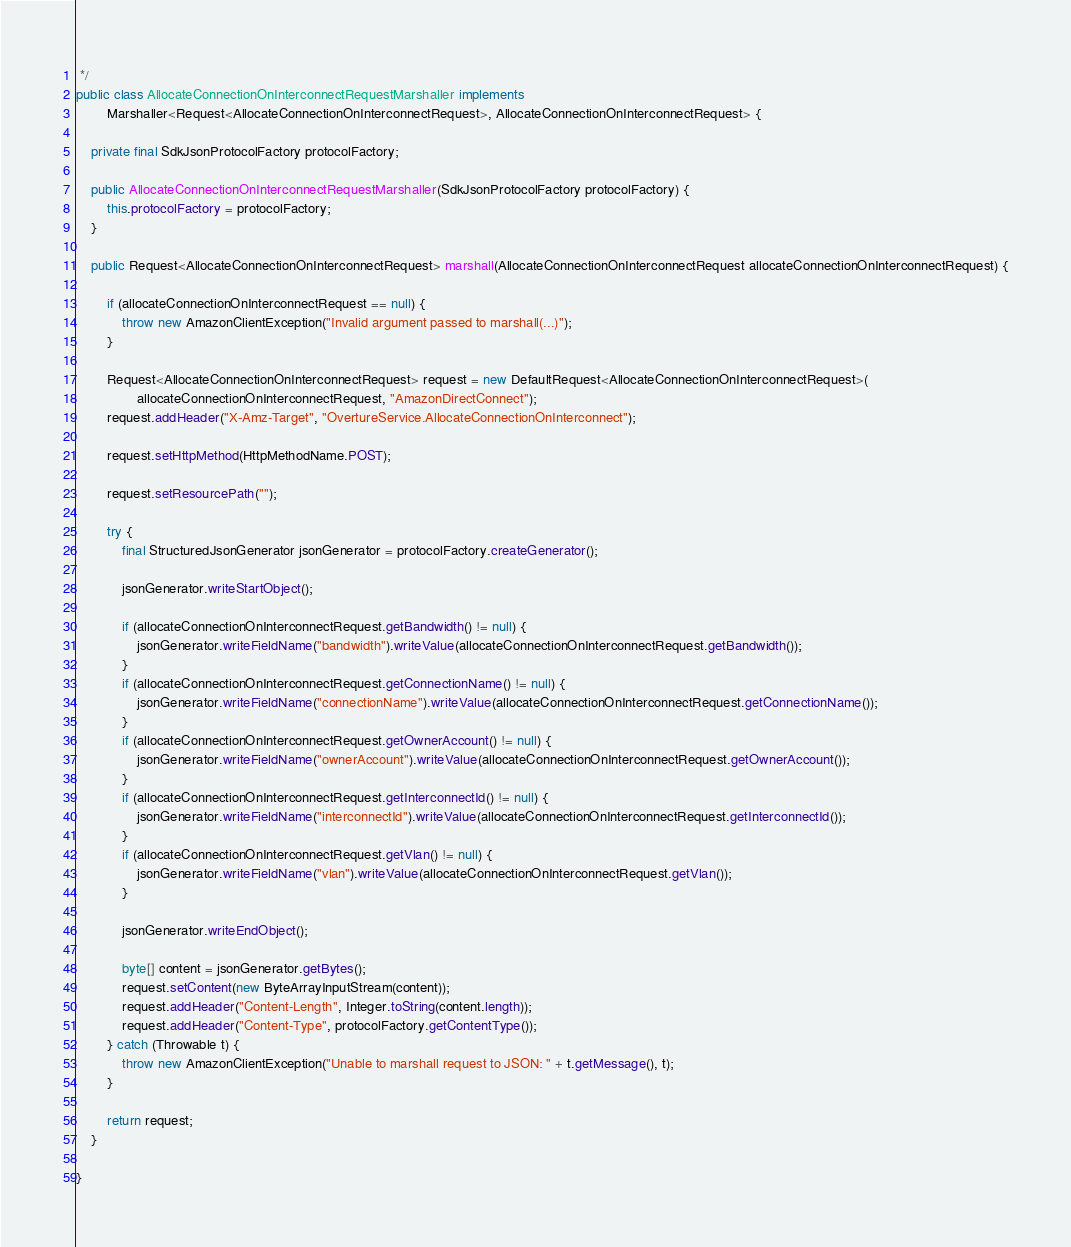<code> <loc_0><loc_0><loc_500><loc_500><_Java_> */
public class AllocateConnectionOnInterconnectRequestMarshaller implements
        Marshaller<Request<AllocateConnectionOnInterconnectRequest>, AllocateConnectionOnInterconnectRequest> {

    private final SdkJsonProtocolFactory protocolFactory;

    public AllocateConnectionOnInterconnectRequestMarshaller(SdkJsonProtocolFactory protocolFactory) {
        this.protocolFactory = protocolFactory;
    }

    public Request<AllocateConnectionOnInterconnectRequest> marshall(AllocateConnectionOnInterconnectRequest allocateConnectionOnInterconnectRequest) {

        if (allocateConnectionOnInterconnectRequest == null) {
            throw new AmazonClientException("Invalid argument passed to marshall(...)");
        }

        Request<AllocateConnectionOnInterconnectRequest> request = new DefaultRequest<AllocateConnectionOnInterconnectRequest>(
                allocateConnectionOnInterconnectRequest, "AmazonDirectConnect");
        request.addHeader("X-Amz-Target", "OvertureService.AllocateConnectionOnInterconnect");

        request.setHttpMethod(HttpMethodName.POST);

        request.setResourcePath("");

        try {
            final StructuredJsonGenerator jsonGenerator = protocolFactory.createGenerator();

            jsonGenerator.writeStartObject();

            if (allocateConnectionOnInterconnectRequest.getBandwidth() != null) {
                jsonGenerator.writeFieldName("bandwidth").writeValue(allocateConnectionOnInterconnectRequest.getBandwidth());
            }
            if (allocateConnectionOnInterconnectRequest.getConnectionName() != null) {
                jsonGenerator.writeFieldName("connectionName").writeValue(allocateConnectionOnInterconnectRequest.getConnectionName());
            }
            if (allocateConnectionOnInterconnectRequest.getOwnerAccount() != null) {
                jsonGenerator.writeFieldName("ownerAccount").writeValue(allocateConnectionOnInterconnectRequest.getOwnerAccount());
            }
            if (allocateConnectionOnInterconnectRequest.getInterconnectId() != null) {
                jsonGenerator.writeFieldName("interconnectId").writeValue(allocateConnectionOnInterconnectRequest.getInterconnectId());
            }
            if (allocateConnectionOnInterconnectRequest.getVlan() != null) {
                jsonGenerator.writeFieldName("vlan").writeValue(allocateConnectionOnInterconnectRequest.getVlan());
            }

            jsonGenerator.writeEndObject();

            byte[] content = jsonGenerator.getBytes();
            request.setContent(new ByteArrayInputStream(content));
            request.addHeader("Content-Length", Integer.toString(content.length));
            request.addHeader("Content-Type", protocolFactory.getContentType());
        } catch (Throwable t) {
            throw new AmazonClientException("Unable to marshall request to JSON: " + t.getMessage(), t);
        }

        return request;
    }

}
</code> 